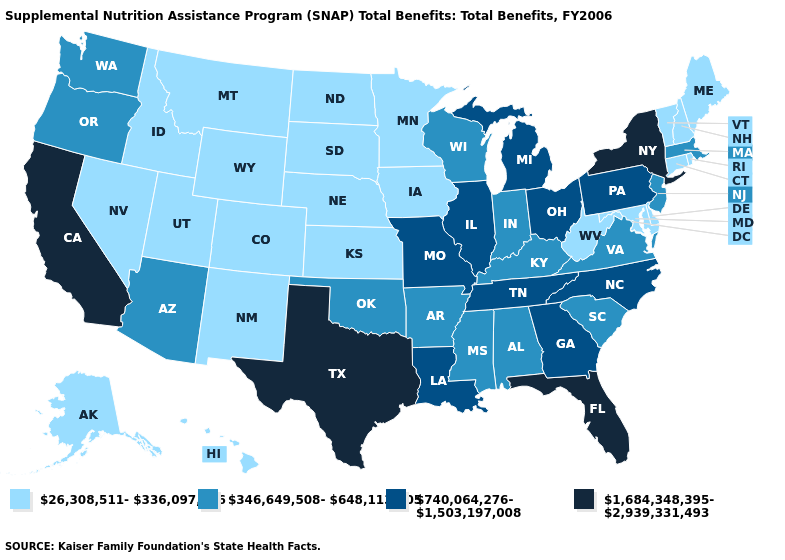Does Connecticut have the lowest value in the USA?
Short answer required. Yes. Which states hav the highest value in the West?
Be succinct. California. What is the lowest value in states that border Tennessee?
Give a very brief answer. 346,649,508-648,113,405. Does the first symbol in the legend represent the smallest category?
Keep it brief. Yes. Does Nebraska have the lowest value in the USA?
Keep it brief. Yes. Name the states that have a value in the range 26,308,511-336,097,166?
Short answer required. Alaska, Colorado, Connecticut, Delaware, Hawaii, Idaho, Iowa, Kansas, Maine, Maryland, Minnesota, Montana, Nebraska, Nevada, New Hampshire, New Mexico, North Dakota, Rhode Island, South Dakota, Utah, Vermont, West Virginia, Wyoming. What is the value of Wyoming?
Be succinct. 26,308,511-336,097,166. Name the states that have a value in the range 1,684,348,395-2,939,331,493?
Give a very brief answer. California, Florida, New York, Texas. What is the value of Indiana?
Short answer required. 346,649,508-648,113,405. What is the highest value in the USA?
Quick response, please. 1,684,348,395-2,939,331,493. What is the highest value in states that border North Carolina?
Write a very short answer. 740,064,276-1,503,197,008. What is the highest value in the USA?
Answer briefly. 1,684,348,395-2,939,331,493. Does North Dakota have a higher value than Indiana?
Write a very short answer. No. Does South Dakota have a lower value than West Virginia?
Answer briefly. No. 